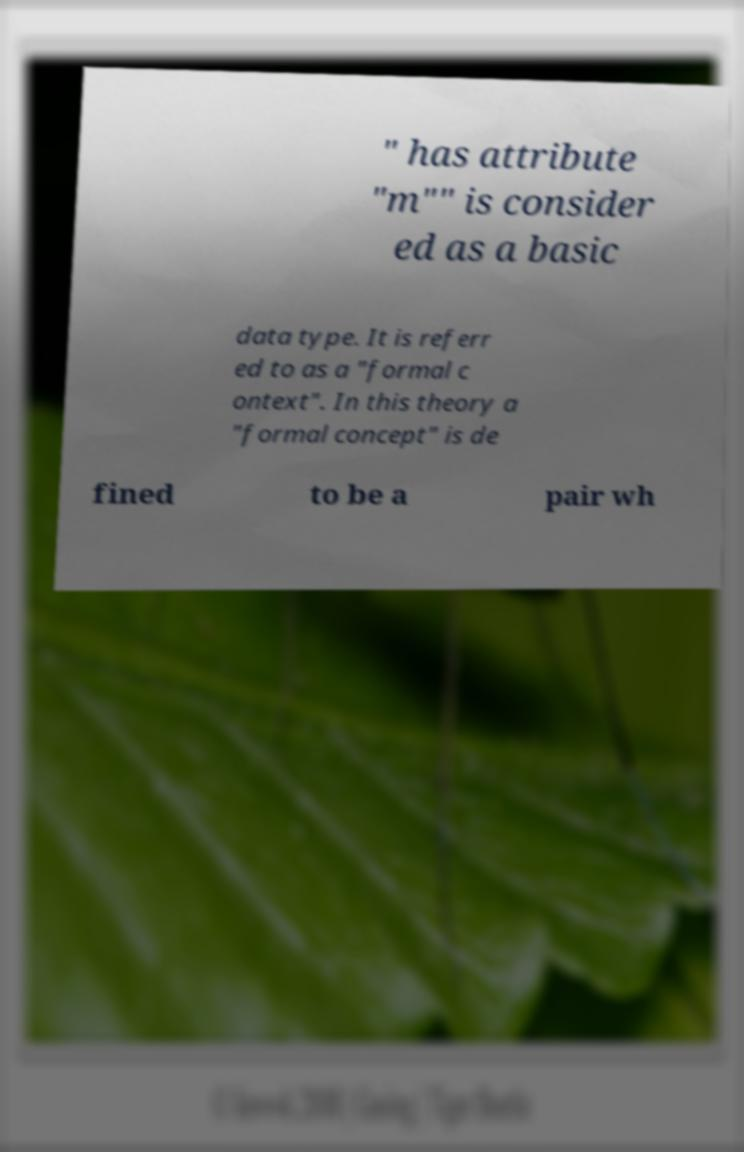Can you accurately transcribe the text from the provided image for me? " has attribute "m"" is consider ed as a basic data type. It is referr ed to as a "formal c ontext". In this theory a "formal concept" is de fined to be a pair wh 